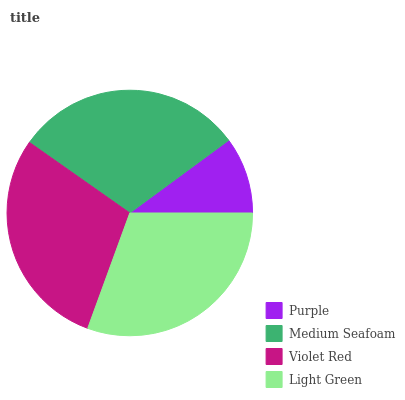Is Purple the minimum?
Answer yes or no. Yes. Is Light Green the maximum?
Answer yes or no. Yes. Is Medium Seafoam the minimum?
Answer yes or no. No. Is Medium Seafoam the maximum?
Answer yes or no. No. Is Medium Seafoam greater than Purple?
Answer yes or no. Yes. Is Purple less than Medium Seafoam?
Answer yes or no. Yes. Is Purple greater than Medium Seafoam?
Answer yes or no. No. Is Medium Seafoam less than Purple?
Answer yes or no. No. Is Medium Seafoam the high median?
Answer yes or no. Yes. Is Violet Red the low median?
Answer yes or no. Yes. Is Purple the high median?
Answer yes or no. No. Is Medium Seafoam the low median?
Answer yes or no. No. 